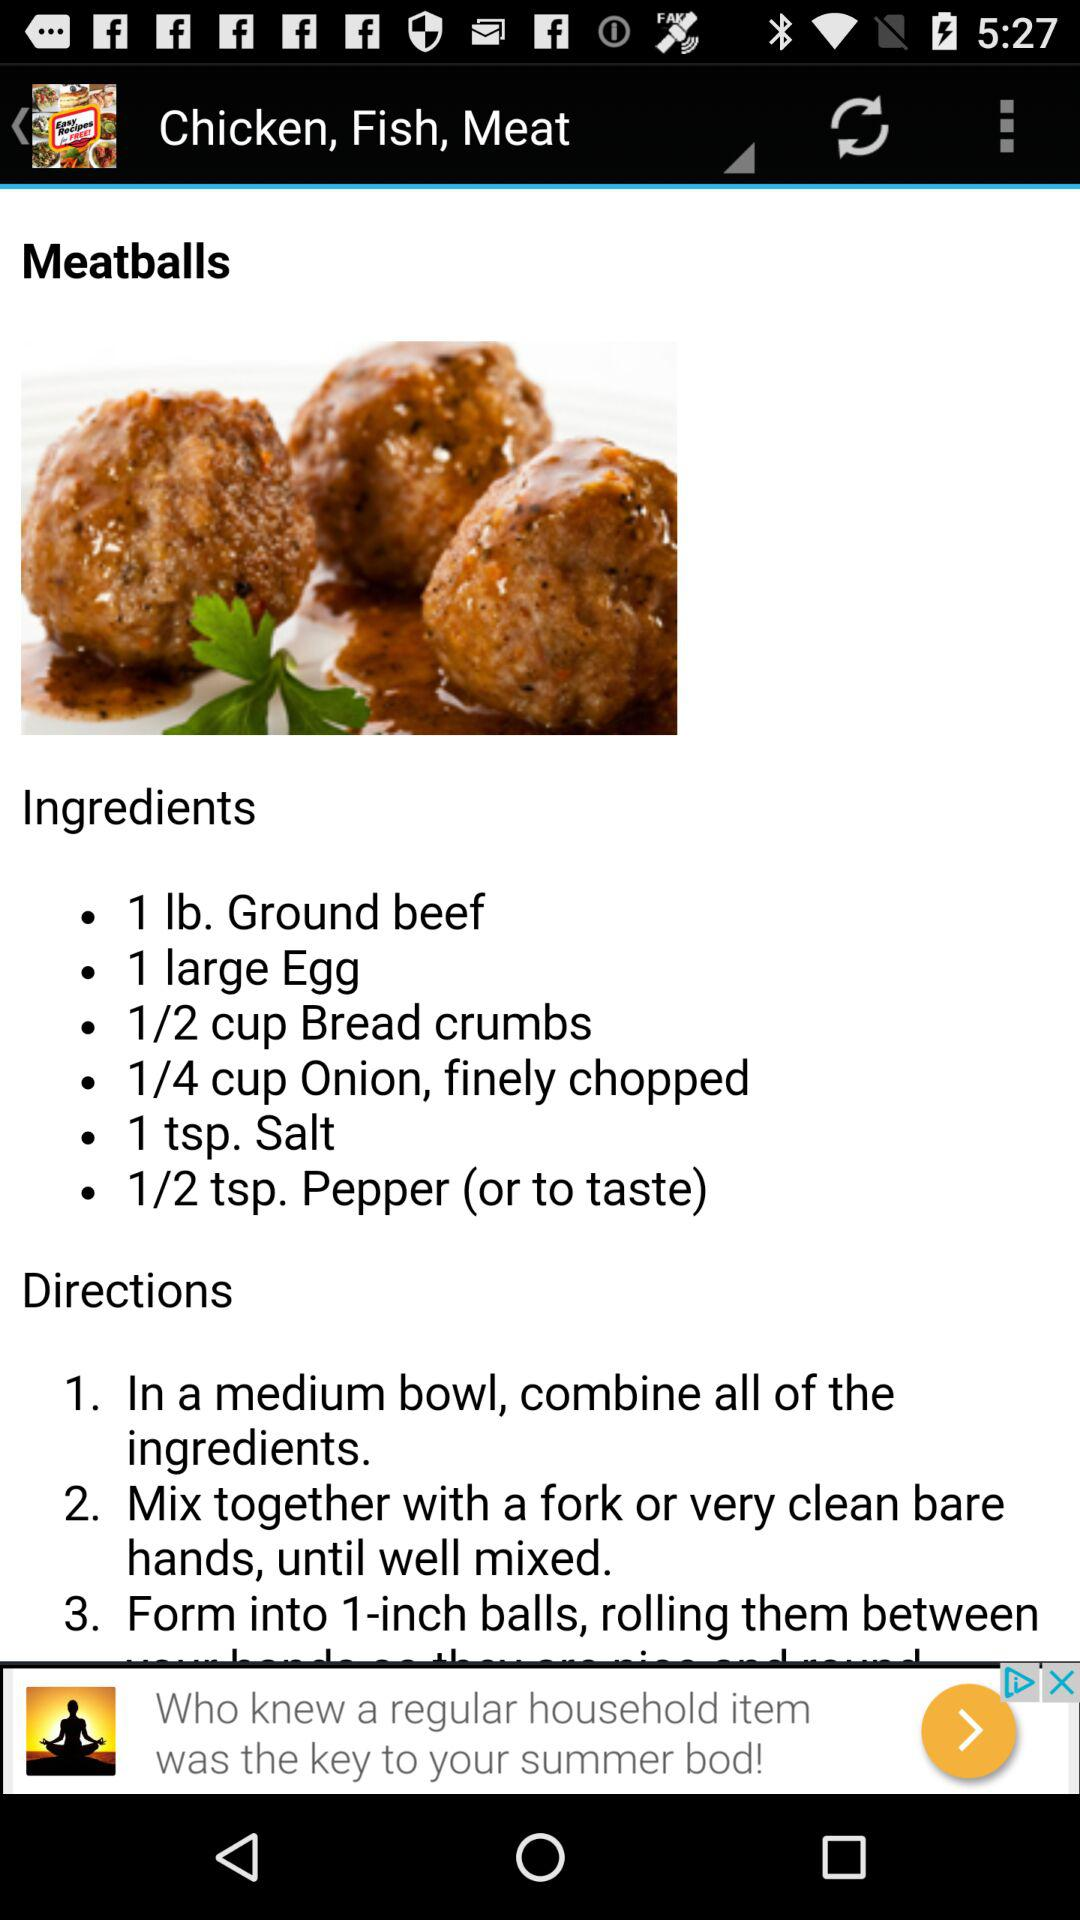Which ingredients are used to cook "Meatballs"? The ingredients are "1 lb. Ground beef", "1 large Egg", "1/2 cup Bread crumbs", "1/4 cup Onion, finely chopped", "1 tsp. Salt" and "1/2 tsp. Pepper (or to taste)". 